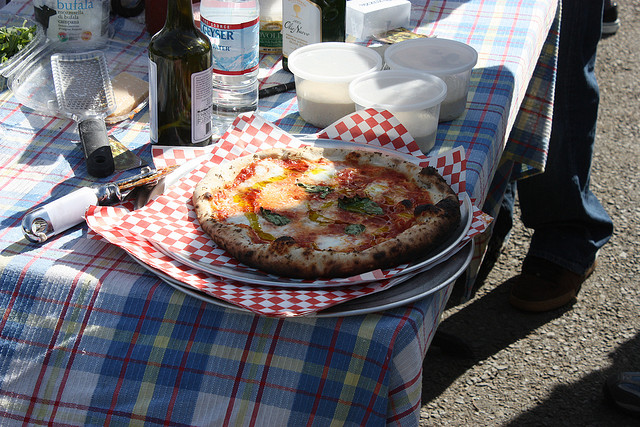Identify the text displayed in this image. bufala GEYSER 